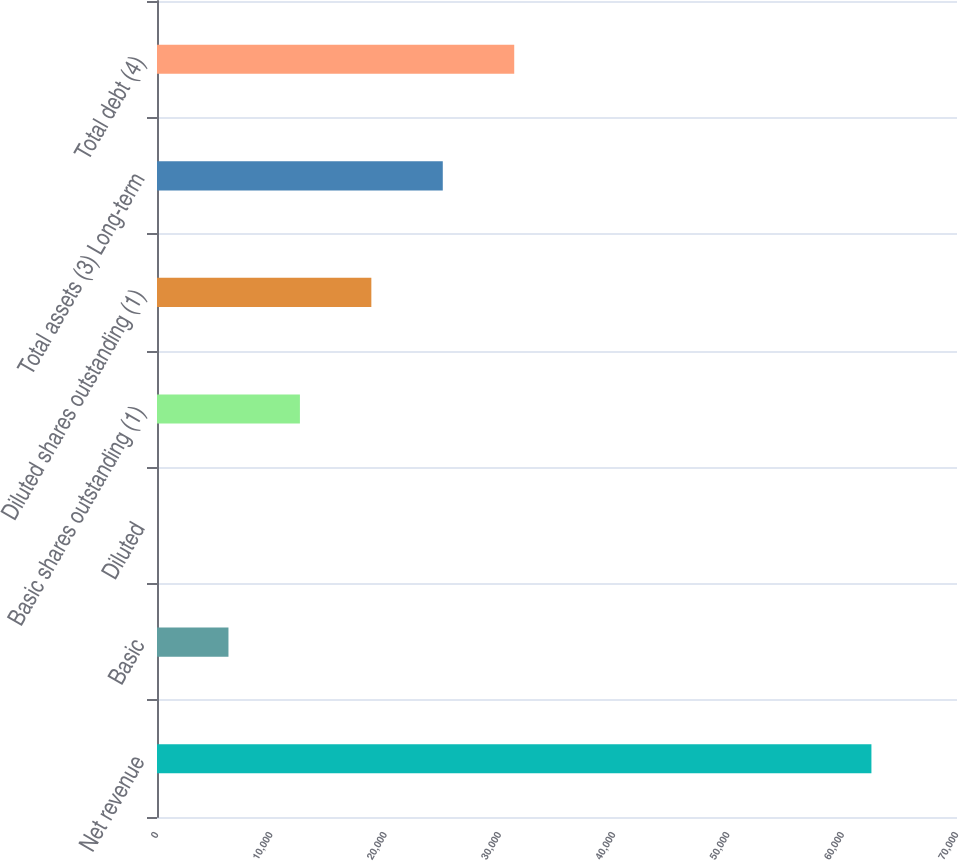Convert chart. <chart><loc_0><loc_0><loc_500><loc_500><bar_chart><fcel>Net revenue<fcel>Basic<fcel>Diluted<fcel>Basic shares outstanding (1)<fcel>Diluted shares outstanding (1)<fcel>Total assets (3) Long-term<fcel>Total debt (4)<nl><fcel>62512<fcel>6253.23<fcel>2.25<fcel>12504.2<fcel>18755.2<fcel>25006.2<fcel>31257.1<nl></chart> 